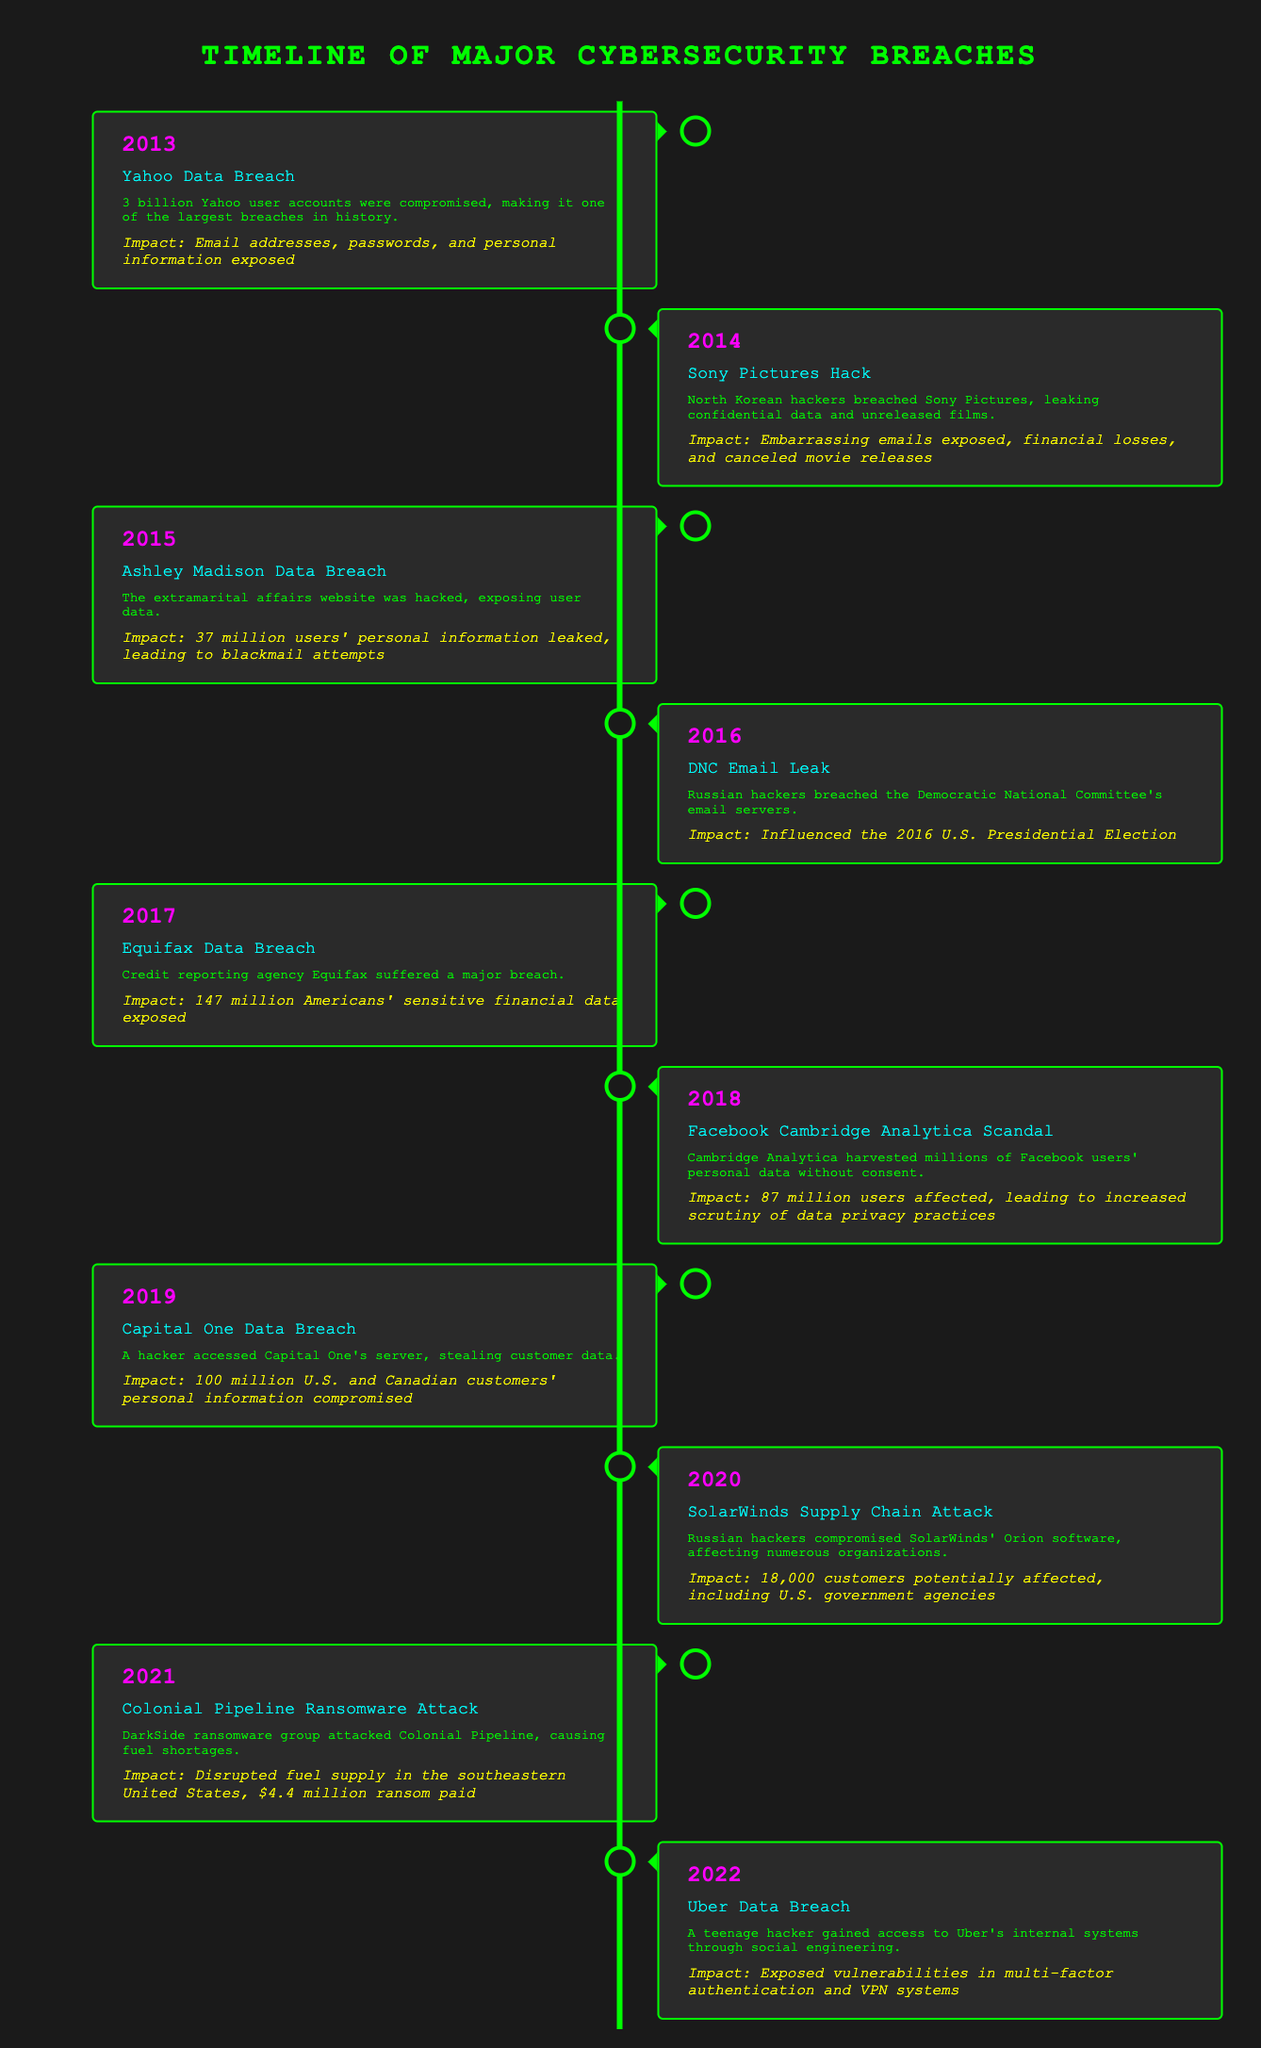What year did the Yahoo Data Breach occur? The table indicates that the event "Yahoo Data Breach" is listed under the year 2013.
Answer: 2013 How many user accounts were compromised in the Yahoo Data Breach? The description for the "Yahoo Data Breach" states that 3 billion user accounts were compromised.
Answer: 3 billion Which breach had an impact on the U.S. Presidential Election? The description for the "DNC Email Leak" from 2016 states that it influenced the 2016 U.S. Presidential Election.
Answer: DNC Email Leak In what year did the Equifax Data Breach occur and how many people's data was exposed? The table shows that the Equifax Data Breach occurred in 2017 and exposed the sensitive financial data of 147 million Americans.
Answer: 2017, 147 million Which breach involved a hacker accessing a server to steal customer data? The "Capital One Data Breach" listed in 2019 involved a hacker accessing Capital One's server to steal customer data as described in the event details.
Answer: Capital One Data Breach True or false: The Facebook Cambridge Analytica Scandal affected 87 million users. According to the impact statement of the "Facebook Cambridge Analytica Scandal," it affected 87 million users which confirms the statement is true.
Answer: True What was the main consequence of the Colonial Pipeline Ransomware Attack? The description for the "Colonial Pipeline Ransomware Attack" states it caused fuel shortages, disrupting fuel supply in the southeastern United States.
Answer: Fuel shortages How many major breaches occurred in 2019 and 2020 combined? From the timeline, there are two events listed: "Capital One Data Breach" in 2019 and "SolarWinds Supply Chain Attack" in 2020, giving a total of two major breaches combined.
Answer: 2 What is the average number of users affected by the breaches from 2015 to 2019? The affected user counts over these years are: 37 million (Ashley Madison), 100 million (Capital One), and for the DNC Email Leak, we are not given a specific number so we'll limit the average to Ashley Madison and Capital One. The total is 37 + 100 = 137 million. Dividing by the 2 years gives us an average of 68.5 million users affected.
Answer: 68.5 million Which event involved a social engineering attack? The event "Uber Data Breach" from 2022 describes that a teenage hacker accessed Uber's internal systems through social engineering.
Answer: Uber Data Breach 